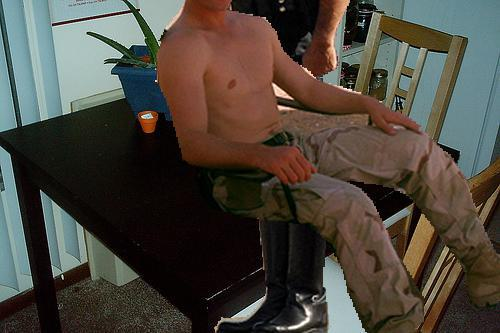Are there any additional objects on the table aside from the plant? Aside from the plant, there appears to be a small, possibly decorative item near the corner of the table, which could be a candle, suggesting an inclination towards a cozy and inviting table setting. 